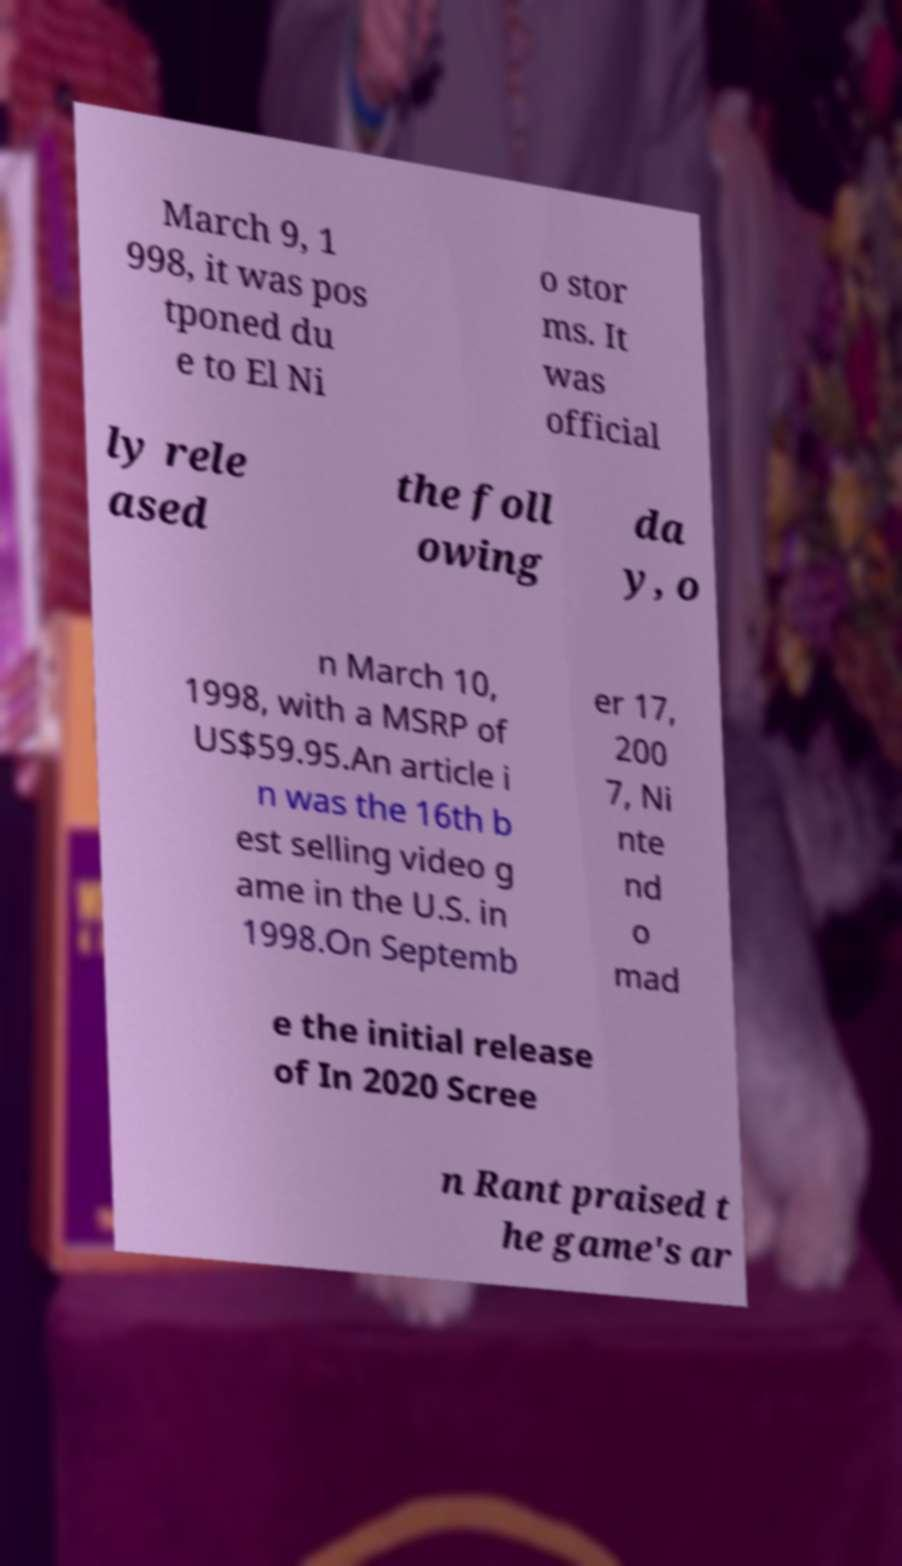I need the written content from this picture converted into text. Can you do that? March 9, 1 998, it was pos tponed du e to El Ni o stor ms. It was official ly rele ased the foll owing da y, o n March 10, 1998, with a MSRP of US$59.95.An article i n was the 16th b est selling video g ame in the U.S. in 1998.On Septemb er 17, 200 7, Ni nte nd o mad e the initial release of In 2020 Scree n Rant praised t he game's ar 